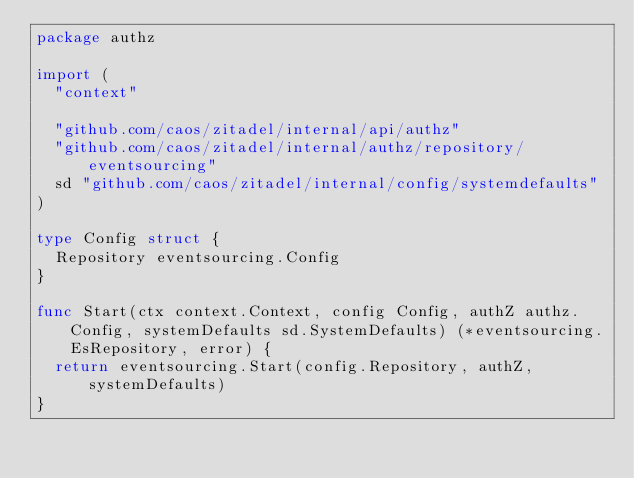Convert code to text. <code><loc_0><loc_0><loc_500><loc_500><_Go_>package authz

import (
	"context"

	"github.com/caos/zitadel/internal/api/authz"
	"github.com/caos/zitadel/internal/authz/repository/eventsourcing"
	sd "github.com/caos/zitadel/internal/config/systemdefaults"
)

type Config struct {
	Repository eventsourcing.Config
}

func Start(ctx context.Context, config Config, authZ authz.Config, systemDefaults sd.SystemDefaults) (*eventsourcing.EsRepository, error) {
	return eventsourcing.Start(config.Repository, authZ, systemDefaults)
}
</code> 